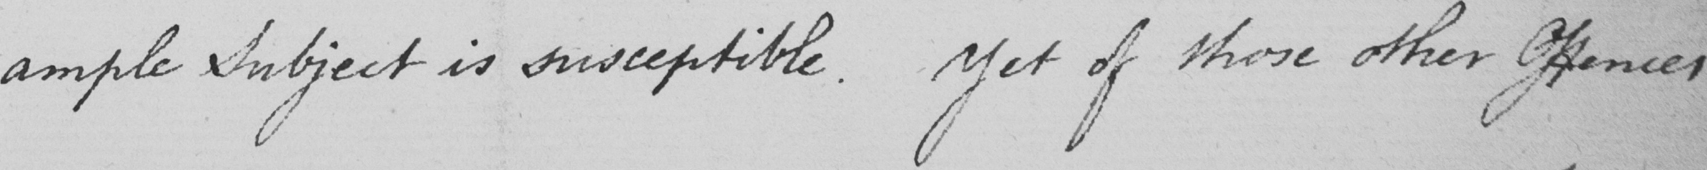Please transcribe the handwritten text in this image. ample Subject is susceptible .  Yet of those whose other Offences 